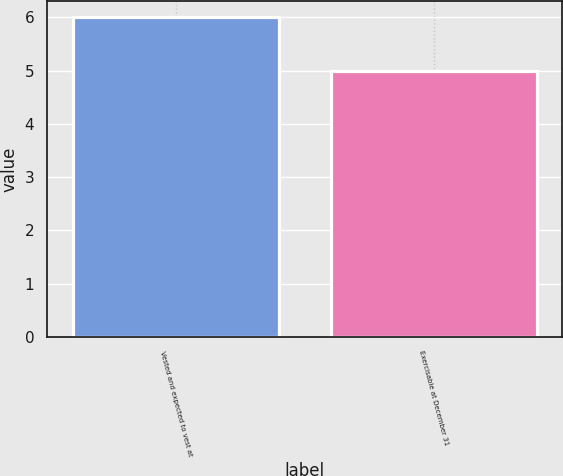<chart> <loc_0><loc_0><loc_500><loc_500><bar_chart><fcel>Vested and expected to vest at<fcel>Exercisable at December 31<nl><fcel>6<fcel>5<nl></chart> 